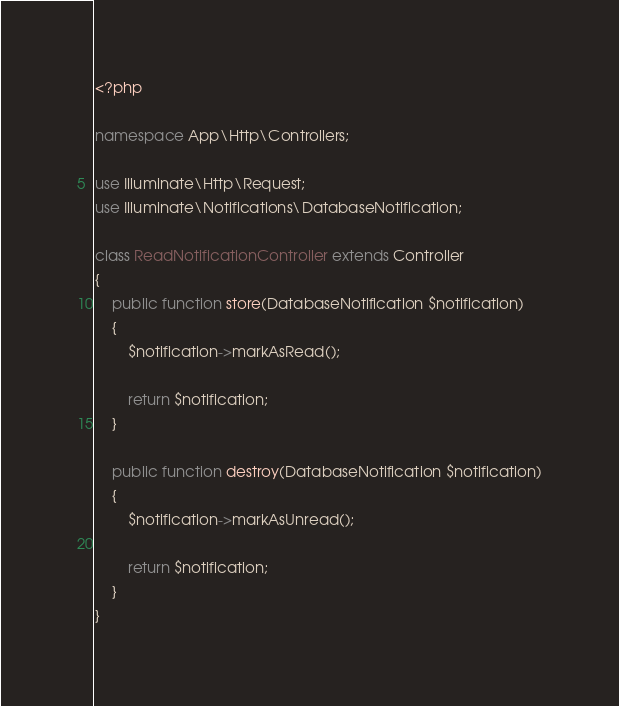<code> <loc_0><loc_0><loc_500><loc_500><_PHP_><?php

namespace App\Http\Controllers;

use Illuminate\Http\Request;
use Illuminate\Notifications\DatabaseNotification;

class ReadNotificationController extends Controller
{
    public function store(DatabaseNotification $notification)
    {
        $notification->markAsRead(); 

        return $notification; 
    }

    public function destroy(DatabaseNotification $notification)
    {
        $notification->markAsUnread(); 

        return $notification; 
    }
}
</code> 